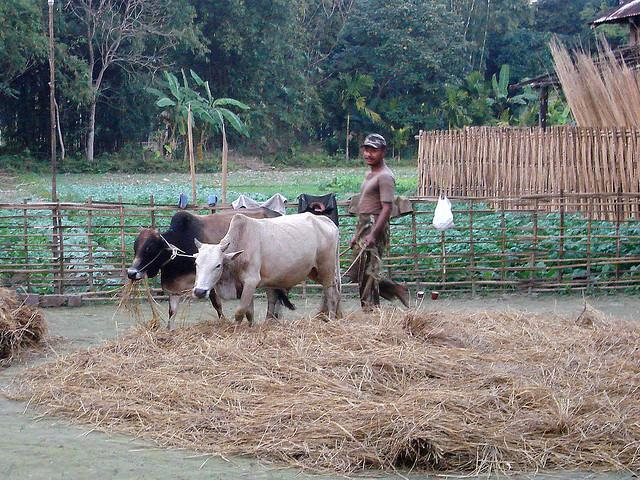What diet are the cows here on? Please explain your reasoning. vegan. The cows are eating hay. 